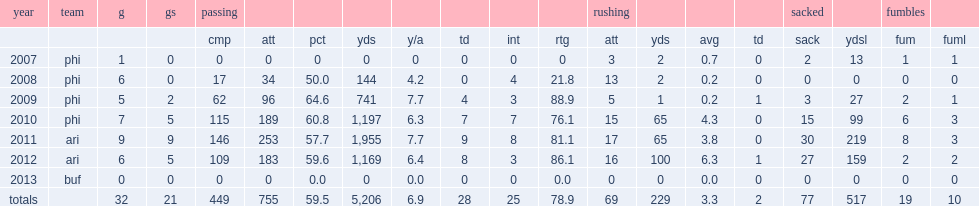How many passes did kolb complete with 34 attempts for 144 yards, throwing no touchdowns and four interceptions during the season 2008? 17.0. 